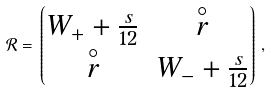<formula> <loc_0><loc_0><loc_500><loc_500>\mathcal { R } = \left \lgroup \begin{matrix} W _ { + } + \frac { s } { 1 2 } & \overset { \circ } { r } \\ \overset { \circ } { r } & W _ { - } + \frac { s } { 1 2 } \end{matrix} \right \rgroup ,</formula> 